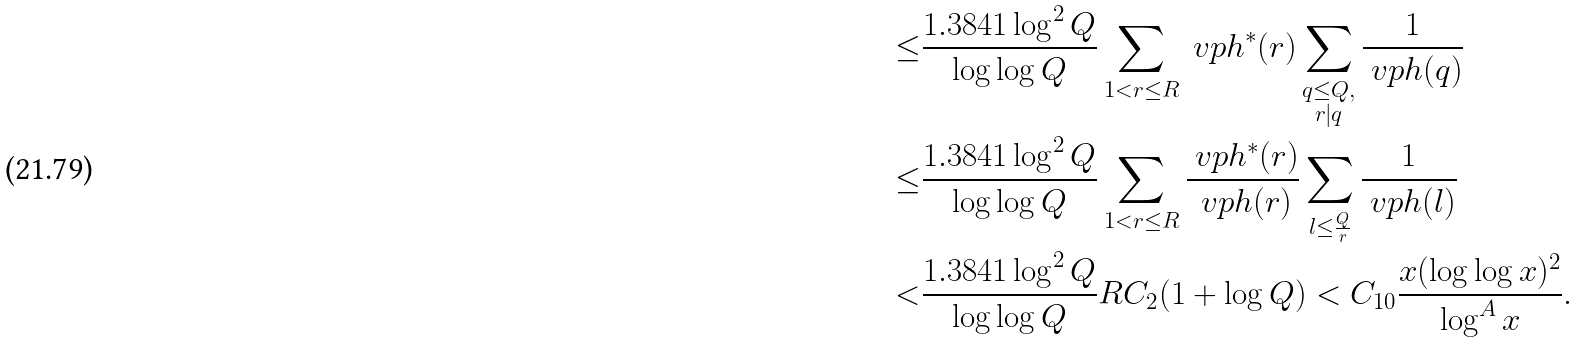<formula> <loc_0><loc_0><loc_500><loc_500>\leq & \frac { 1 . 3 8 4 1 \log ^ { 2 } Q } { \log \log Q } \sum _ { 1 < r \leq R } \ v p h ^ { * } ( r ) \sum _ { \substack { q \leq Q , \\ r | q } } \frac { 1 } { \ v p h ( q ) } \\ \leq & \frac { 1 . 3 8 4 1 \log ^ { 2 } Q } { \log \log Q } \sum _ { 1 < r \leq R } \frac { \ v p h ^ { * } ( r ) } { \ v p h ( r ) } \sum _ { \substack { l \leq \frac { Q } { r } } } \frac { 1 } { \ v p h ( l ) } \\ < & \frac { 1 . 3 8 4 1 \log ^ { 2 } Q } { \log \log Q } R C _ { 2 } ( 1 + \log Q ) < C _ { 1 0 } \frac { x ( \log \log x ) ^ { 2 } } { \log ^ { A } x } .</formula> 